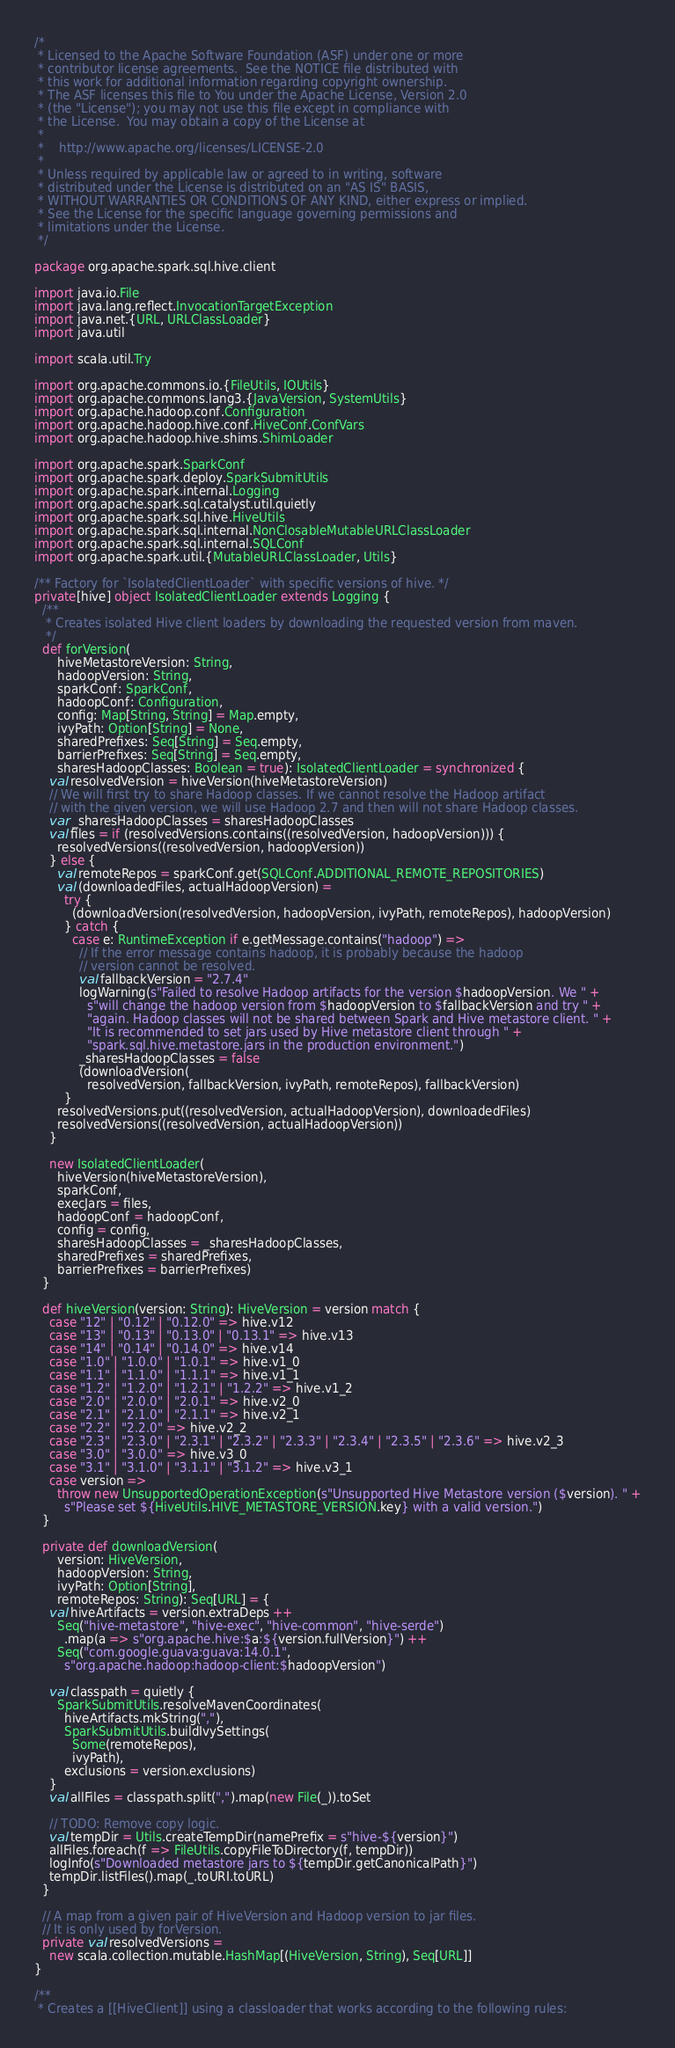Convert code to text. <code><loc_0><loc_0><loc_500><loc_500><_Scala_>/*
 * Licensed to the Apache Software Foundation (ASF) under one or more
 * contributor license agreements.  See the NOTICE file distributed with
 * this work for additional information regarding copyright ownership.
 * The ASF licenses this file to You under the Apache License, Version 2.0
 * (the "License"); you may not use this file except in compliance with
 * the License.  You may obtain a copy of the License at
 *
 *    http://www.apache.org/licenses/LICENSE-2.0
 *
 * Unless required by applicable law or agreed to in writing, software
 * distributed under the License is distributed on an "AS IS" BASIS,
 * WITHOUT WARRANTIES OR CONDITIONS OF ANY KIND, either express or implied.
 * See the License for the specific language governing permissions and
 * limitations under the License.
 */

package org.apache.spark.sql.hive.client

import java.io.File
import java.lang.reflect.InvocationTargetException
import java.net.{URL, URLClassLoader}
import java.util

import scala.util.Try

import org.apache.commons.io.{FileUtils, IOUtils}
import org.apache.commons.lang3.{JavaVersion, SystemUtils}
import org.apache.hadoop.conf.Configuration
import org.apache.hadoop.hive.conf.HiveConf.ConfVars
import org.apache.hadoop.hive.shims.ShimLoader

import org.apache.spark.SparkConf
import org.apache.spark.deploy.SparkSubmitUtils
import org.apache.spark.internal.Logging
import org.apache.spark.sql.catalyst.util.quietly
import org.apache.spark.sql.hive.HiveUtils
import org.apache.spark.sql.internal.NonClosableMutableURLClassLoader
import org.apache.spark.sql.internal.SQLConf
import org.apache.spark.util.{MutableURLClassLoader, Utils}

/** Factory for `IsolatedClientLoader` with specific versions of hive. */
private[hive] object IsolatedClientLoader extends Logging {
  /**
   * Creates isolated Hive client loaders by downloading the requested version from maven.
   */
  def forVersion(
      hiveMetastoreVersion: String,
      hadoopVersion: String,
      sparkConf: SparkConf,
      hadoopConf: Configuration,
      config: Map[String, String] = Map.empty,
      ivyPath: Option[String] = None,
      sharedPrefixes: Seq[String] = Seq.empty,
      barrierPrefixes: Seq[String] = Seq.empty,
      sharesHadoopClasses: Boolean = true): IsolatedClientLoader = synchronized {
    val resolvedVersion = hiveVersion(hiveMetastoreVersion)
    // We will first try to share Hadoop classes. If we cannot resolve the Hadoop artifact
    // with the given version, we will use Hadoop 2.7 and then will not share Hadoop classes.
    var _sharesHadoopClasses = sharesHadoopClasses
    val files = if (resolvedVersions.contains((resolvedVersion, hadoopVersion))) {
      resolvedVersions((resolvedVersion, hadoopVersion))
    } else {
      val remoteRepos = sparkConf.get(SQLConf.ADDITIONAL_REMOTE_REPOSITORIES)
      val (downloadedFiles, actualHadoopVersion) =
        try {
          (downloadVersion(resolvedVersion, hadoopVersion, ivyPath, remoteRepos), hadoopVersion)
        } catch {
          case e: RuntimeException if e.getMessage.contains("hadoop") =>
            // If the error message contains hadoop, it is probably because the hadoop
            // version cannot be resolved.
            val fallbackVersion = "2.7.4"
            logWarning(s"Failed to resolve Hadoop artifacts for the version $hadoopVersion. We " +
              s"will change the hadoop version from $hadoopVersion to $fallbackVersion and try " +
              "again. Hadoop classes will not be shared between Spark and Hive metastore client. " +
              "It is recommended to set jars used by Hive metastore client through " +
              "spark.sql.hive.metastore.jars in the production environment.")
            _sharesHadoopClasses = false
            (downloadVersion(
              resolvedVersion, fallbackVersion, ivyPath, remoteRepos), fallbackVersion)
        }
      resolvedVersions.put((resolvedVersion, actualHadoopVersion), downloadedFiles)
      resolvedVersions((resolvedVersion, actualHadoopVersion))
    }

    new IsolatedClientLoader(
      hiveVersion(hiveMetastoreVersion),
      sparkConf,
      execJars = files,
      hadoopConf = hadoopConf,
      config = config,
      sharesHadoopClasses = _sharesHadoopClasses,
      sharedPrefixes = sharedPrefixes,
      barrierPrefixes = barrierPrefixes)
  }

  def hiveVersion(version: String): HiveVersion = version match {
    case "12" | "0.12" | "0.12.0" => hive.v12
    case "13" | "0.13" | "0.13.0" | "0.13.1" => hive.v13
    case "14" | "0.14" | "0.14.0" => hive.v14
    case "1.0" | "1.0.0" | "1.0.1" => hive.v1_0
    case "1.1" | "1.1.0" | "1.1.1" => hive.v1_1
    case "1.2" | "1.2.0" | "1.2.1" | "1.2.2" => hive.v1_2
    case "2.0" | "2.0.0" | "2.0.1" => hive.v2_0
    case "2.1" | "2.1.0" | "2.1.1" => hive.v2_1
    case "2.2" | "2.2.0" => hive.v2_2
    case "2.3" | "2.3.0" | "2.3.1" | "2.3.2" | "2.3.3" | "2.3.4" | "2.3.5" | "2.3.6" => hive.v2_3
    case "3.0" | "3.0.0" => hive.v3_0
    case "3.1" | "3.1.0" | "3.1.1" | "3.1.2" => hive.v3_1
    case version =>
      throw new UnsupportedOperationException(s"Unsupported Hive Metastore version ($version). " +
        s"Please set ${HiveUtils.HIVE_METASTORE_VERSION.key} with a valid version.")
  }

  private def downloadVersion(
      version: HiveVersion,
      hadoopVersion: String,
      ivyPath: Option[String],
      remoteRepos: String): Seq[URL] = {
    val hiveArtifacts = version.extraDeps ++
      Seq("hive-metastore", "hive-exec", "hive-common", "hive-serde")
        .map(a => s"org.apache.hive:$a:${version.fullVersion}") ++
      Seq("com.google.guava:guava:14.0.1",
        s"org.apache.hadoop:hadoop-client:$hadoopVersion")

    val classpath = quietly {
      SparkSubmitUtils.resolveMavenCoordinates(
        hiveArtifacts.mkString(","),
        SparkSubmitUtils.buildIvySettings(
          Some(remoteRepos),
          ivyPath),
        exclusions = version.exclusions)
    }
    val allFiles = classpath.split(",").map(new File(_)).toSet

    // TODO: Remove copy logic.
    val tempDir = Utils.createTempDir(namePrefix = s"hive-${version}")
    allFiles.foreach(f => FileUtils.copyFileToDirectory(f, tempDir))
    logInfo(s"Downloaded metastore jars to ${tempDir.getCanonicalPath}")
    tempDir.listFiles().map(_.toURI.toURL)
  }

  // A map from a given pair of HiveVersion and Hadoop version to jar files.
  // It is only used by forVersion.
  private val resolvedVersions =
    new scala.collection.mutable.HashMap[(HiveVersion, String), Seq[URL]]
}

/**
 * Creates a [[HiveClient]] using a classloader that works according to the following rules:</code> 